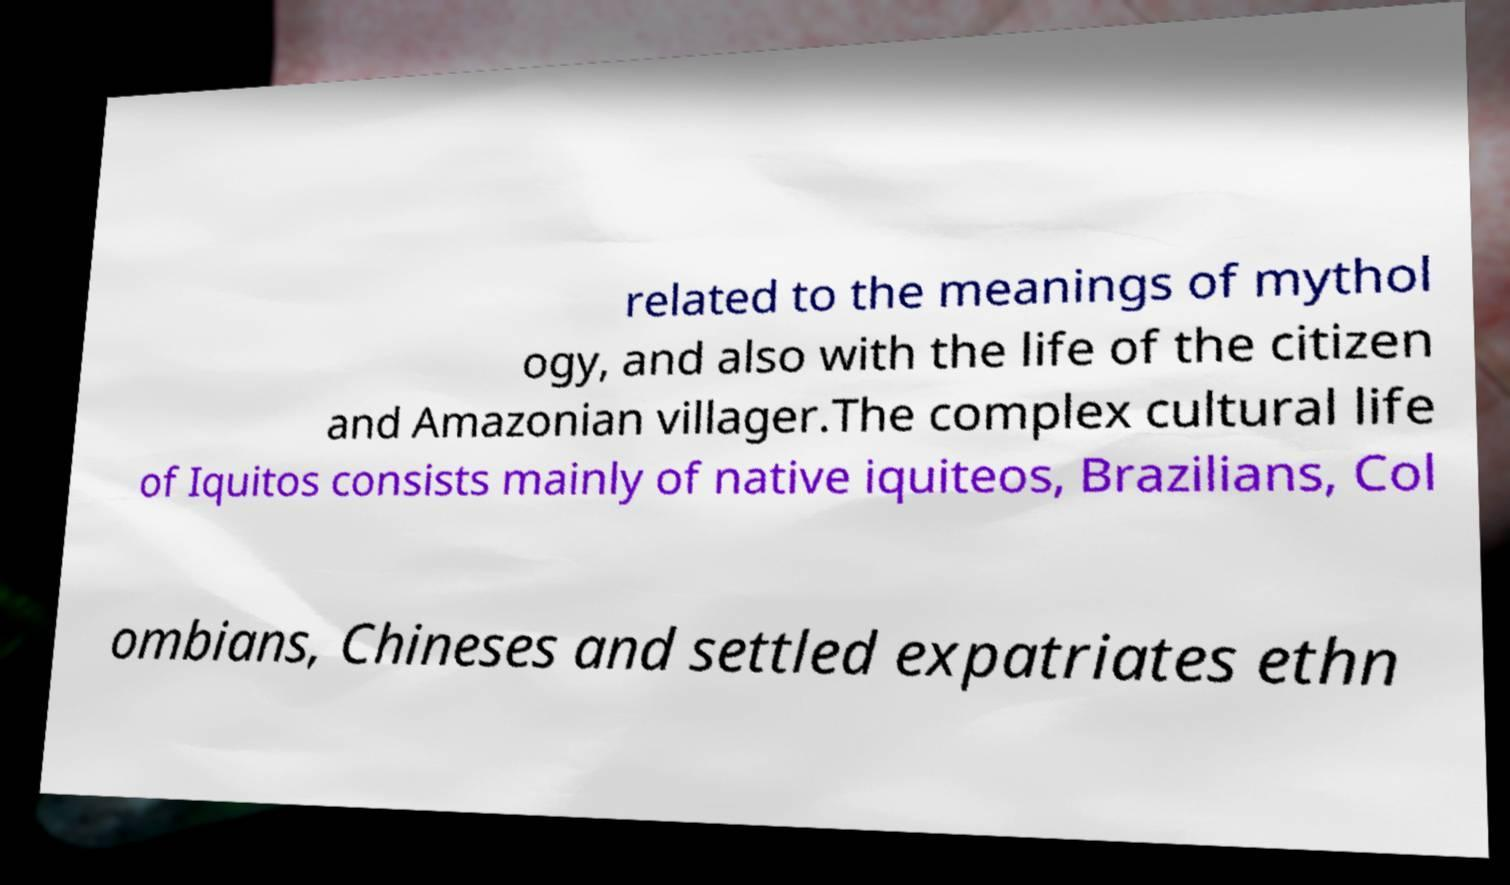I need the written content from this picture converted into text. Can you do that? related to the meanings of mythol ogy, and also with the life of the citizen and Amazonian villager.The complex cultural life of Iquitos consists mainly of native iquiteos, Brazilians, Col ombians, Chineses and settled expatriates ethn 